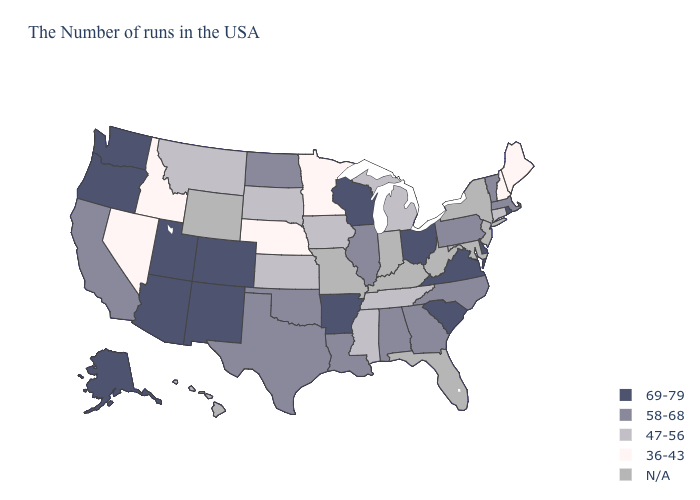Does the map have missing data?
Give a very brief answer. Yes. What is the highest value in the West ?
Concise answer only. 69-79. What is the value of Massachusetts?
Concise answer only. 58-68. Name the states that have a value in the range 58-68?
Write a very short answer. Massachusetts, Vermont, Pennsylvania, North Carolina, Georgia, Alabama, Illinois, Louisiana, Oklahoma, Texas, North Dakota, California. What is the value of Kentucky?
Write a very short answer. N/A. What is the value of Nebraska?
Short answer required. 36-43. Which states have the highest value in the USA?
Write a very short answer. Rhode Island, Delaware, Virginia, South Carolina, Ohio, Wisconsin, Arkansas, Colorado, New Mexico, Utah, Arizona, Washington, Oregon, Alaska. What is the value of Oregon?
Keep it brief. 69-79. Among the states that border New Hampshire , does Maine have the highest value?
Keep it brief. No. What is the lowest value in the USA?
Be succinct. 36-43. What is the highest value in states that border North Carolina?
Give a very brief answer. 69-79. Name the states that have a value in the range 58-68?
Be succinct. Massachusetts, Vermont, Pennsylvania, North Carolina, Georgia, Alabama, Illinois, Louisiana, Oklahoma, Texas, North Dakota, California. Name the states that have a value in the range 69-79?
Short answer required. Rhode Island, Delaware, Virginia, South Carolina, Ohio, Wisconsin, Arkansas, Colorado, New Mexico, Utah, Arizona, Washington, Oregon, Alaska. Among the states that border Florida , which have the highest value?
Write a very short answer. Georgia, Alabama. What is the value of Colorado?
Be succinct. 69-79. 